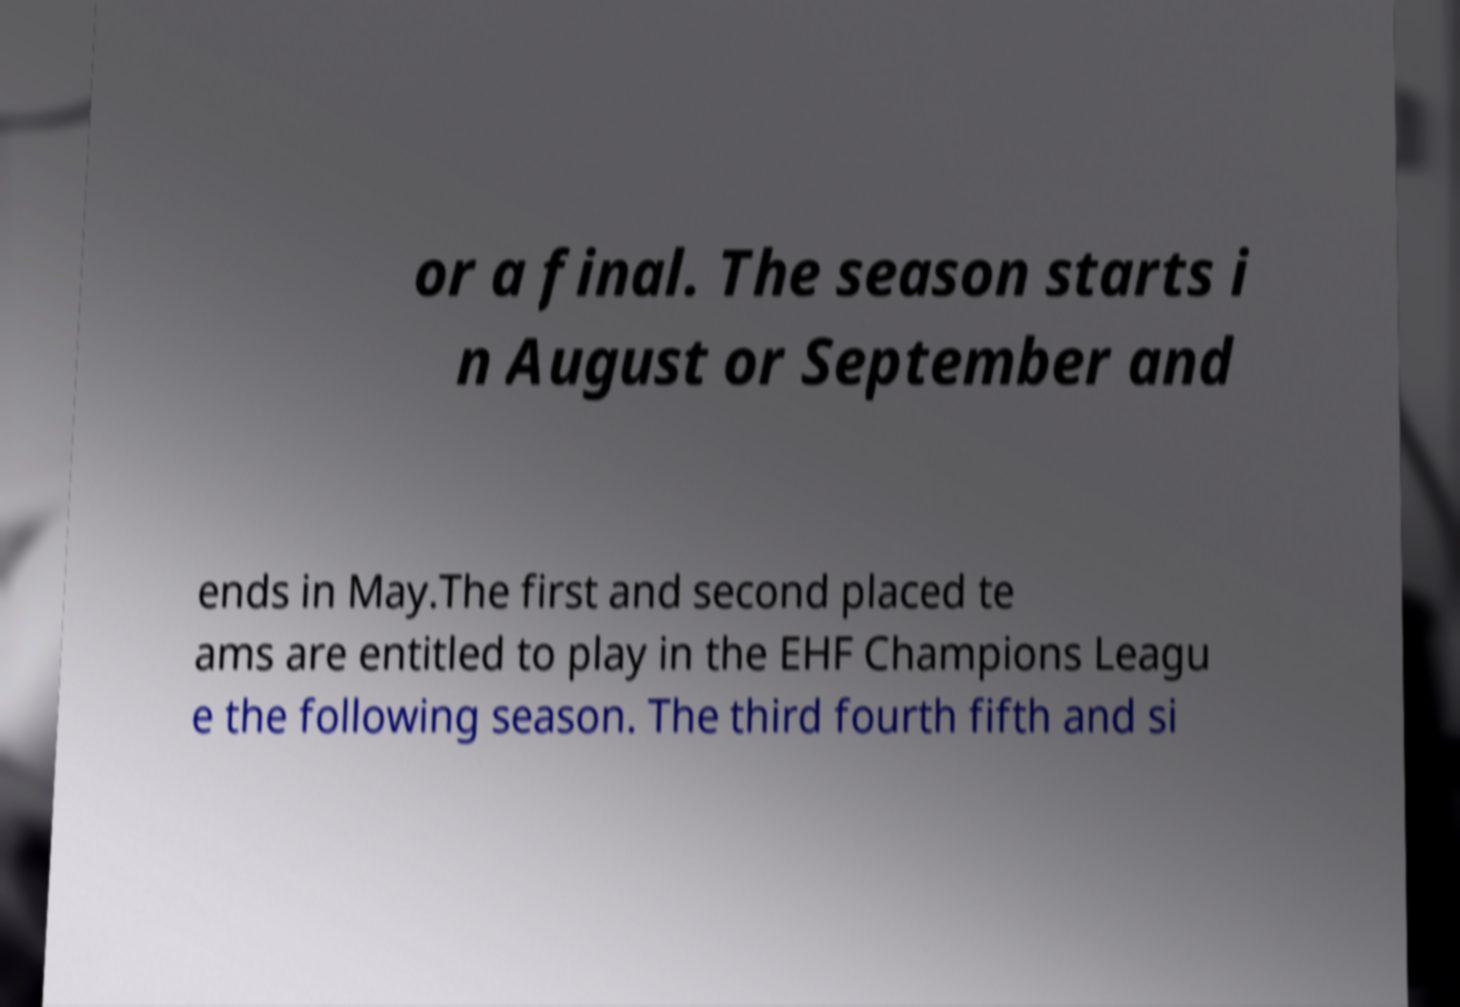For documentation purposes, I need the text within this image transcribed. Could you provide that? or a final. The season starts i n August or September and ends in May.The first and second placed te ams are entitled to play in the EHF Champions Leagu e the following season. The third fourth fifth and si 